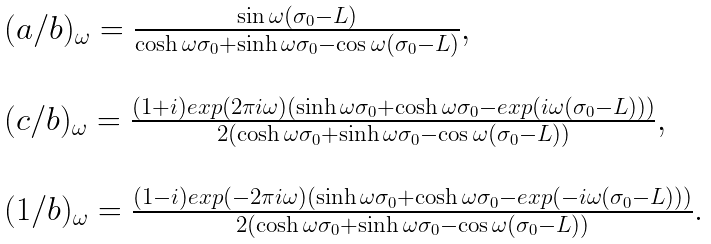Convert formula to latex. <formula><loc_0><loc_0><loc_500><loc_500>\begin{array} { l l } ( a / b ) _ { \omega } = \frac { \sin \omega ( \sigma _ { 0 } - L ) } { \cosh \omega \sigma _ { 0 } + \sinh \omega \sigma _ { 0 } - \cos \omega ( \sigma _ { 0 } - L ) } , \\ \\ ( c / b ) _ { \omega } = \frac { ( 1 + i ) e x p ( 2 \pi i \omega ) ( \sinh \omega \sigma _ { 0 } + \cosh \omega \sigma _ { 0 } - e x p ( i \omega ( \sigma _ { 0 } - L ) ) ) } { 2 ( \cosh \omega \sigma _ { 0 } + \sinh \omega \sigma _ { 0 } - \cos \omega ( \sigma _ { 0 } - L ) ) } , \\ \\ ( 1 / b ) _ { \omega } = \frac { ( 1 - i ) e x p ( - 2 \pi i \omega ) ( \sinh \omega \sigma _ { 0 } + \cosh \omega \sigma _ { 0 } - e x p ( - i \omega ( \sigma _ { 0 } - L ) ) ) } { 2 ( \cosh \omega \sigma _ { 0 } + \sinh \omega \sigma _ { 0 } - \cos \omega ( \sigma _ { 0 } - L ) ) } . \\ \end{array}</formula> 